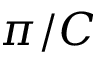Convert formula to latex. <formula><loc_0><loc_0><loc_500><loc_500>\pi / C</formula> 